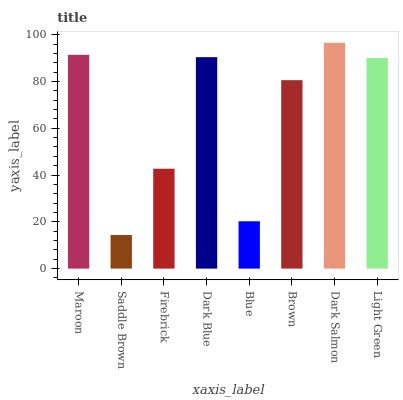Is Saddle Brown the minimum?
Answer yes or no. Yes. Is Dark Salmon the maximum?
Answer yes or no. Yes. Is Firebrick the minimum?
Answer yes or no. No. Is Firebrick the maximum?
Answer yes or no. No. Is Firebrick greater than Saddle Brown?
Answer yes or no. Yes. Is Saddle Brown less than Firebrick?
Answer yes or no. Yes. Is Saddle Brown greater than Firebrick?
Answer yes or no. No. Is Firebrick less than Saddle Brown?
Answer yes or no. No. Is Light Green the high median?
Answer yes or no. Yes. Is Brown the low median?
Answer yes or no. Yes. Is Saddle Brown the high median?
Answer yes or no. No. Is Blue the low median?
Answer yes or no. No. 